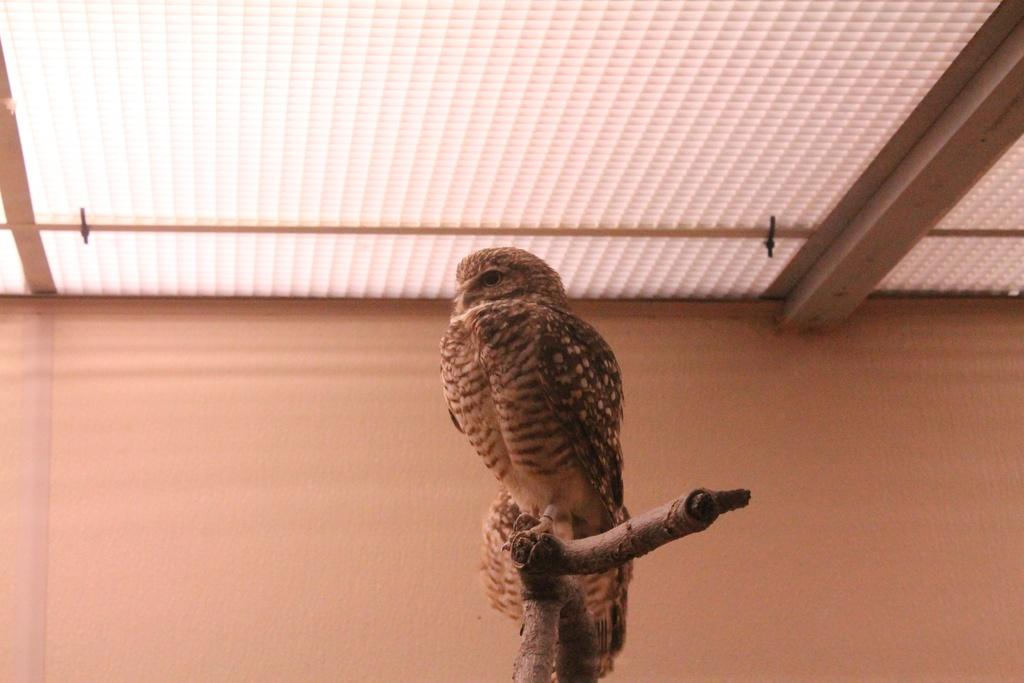What animal can be seen in the image? There is an owl in the image. Where is the owl located? The owl is sitting on a stem. What can be seen in the background of the image? There is a wall in the background of the image. What is visible at the top of the image? There is a roof visible at the top of the image. What type of crayon is the owl using to draw on the wall in the image? There is no crayon present in the image, and the owl is not drawing on the wall. 